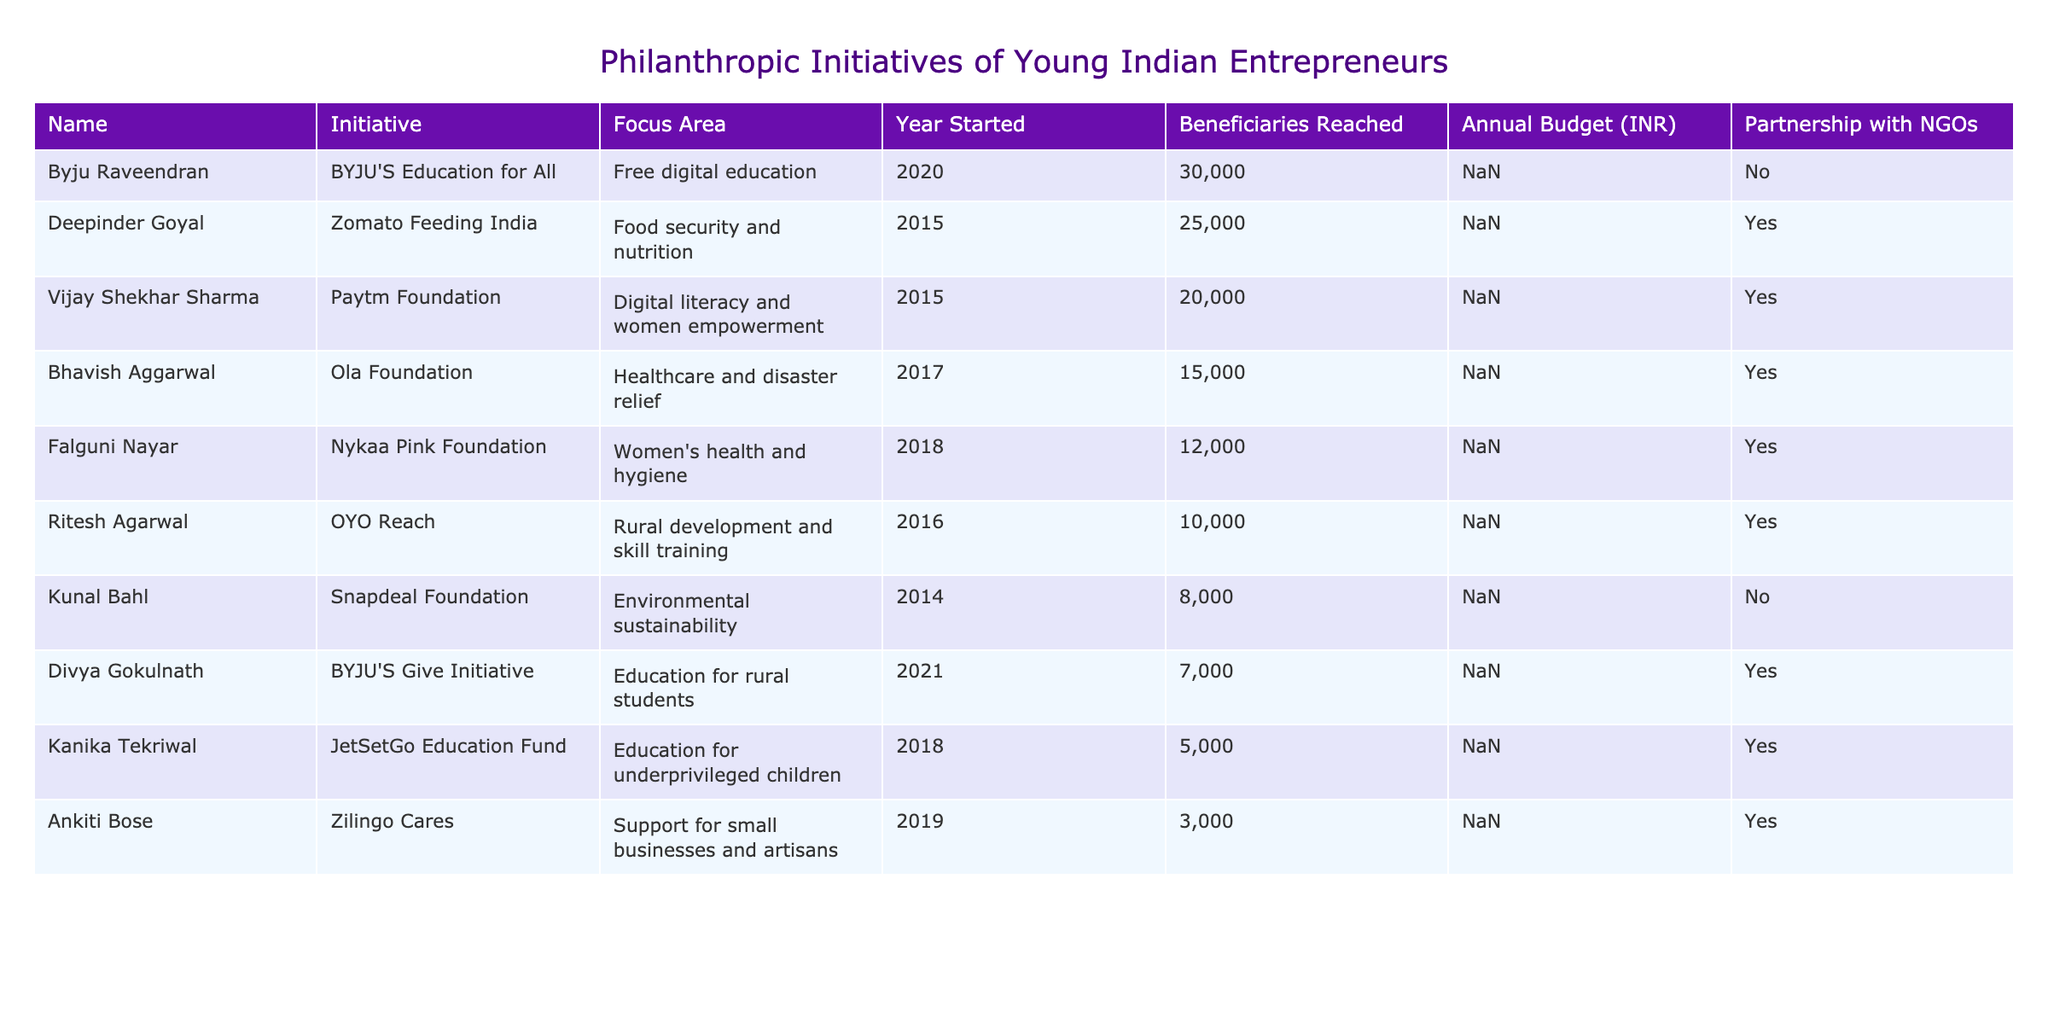What is the focus area of the JetSetGo Education Fund? The table lists the focus area for the JetSetGo Education Fund under Kanika Tekriwal, which is "Education for underprivileged children."
Answer: Education for underprivileged children How many beneficiaries did the Paytm Foundation reach? By looking at the row for the Paytm Foundation, I can see that it reached 20,000 beneficiaries, as stated in the "Beneficiaries Reached" column.
Answer: 20000 Which initiative has the highest annual budget? The annual budget for Ola Foundation is 5 crore, while others have lower budgets. Thus, I compare each value and establish that the Ola Foundation has the highest budget of 5 crore.
Answer: 5 crore What is the difference in beneficiaries reached between BYJU'S Education for All and Zomato Feeding India? BYJU'S Education for All reached 30,000 beneficiaries, while Zomato Feeding India reached 25,000 beneficiaries. The difference is 30,000 - 25,000, which equals 5,000.
Answer: 5000 Did Ankiti Bose's Zilingo Cares have a partnership with NGOs? Looking at the specific row for Zilingo Cares, the table shows that it does have a partnership with NGOs marked as "Yes."
Answer: Yes What is the total annual budget of initiatives started in or after 2018? I sum the annual budgets for initiatives that started in 2018 or later: 1.5 crore (JetSetGo) + 4 crore (Nykaa Pink) + 2.5 crore (BYJU'S Give) + 1 crore (Zilingo Cares) = 9 crore total.
Answer: 9 crore Which initiatives focus on education, and how many beneficiaries did they reach in total? The initiatives focusing on education are JetSetGo Education Fund (5,000 beneficiaries), BYJU'S Education for All (30,000), and BYJU'S Give Initiative (7,000). The total is 5,000 + 30,000 + 7,000 = 42,000 beneficiaries.
Answer: 42000 Is the Nykaa Pink Foundation focused on women’s health? The table states that the Nykaa Pink Foundation's focus area is "Women's health and hygiene." So, this statement is true based on the given information.
Answer: Yes What is the average number of beneficiaries reached by all initiatives listed in the table? First, I sum the number of beneficiaries: 5000 + 10000 + 15000 + 20000 + 8000 + 3000 + 25000 + 30000 + 12000 + 7000 = 115000. Then I divide by the 10 initiatives listed, so 115000 / 10 = 11500.
Answer: 11500 